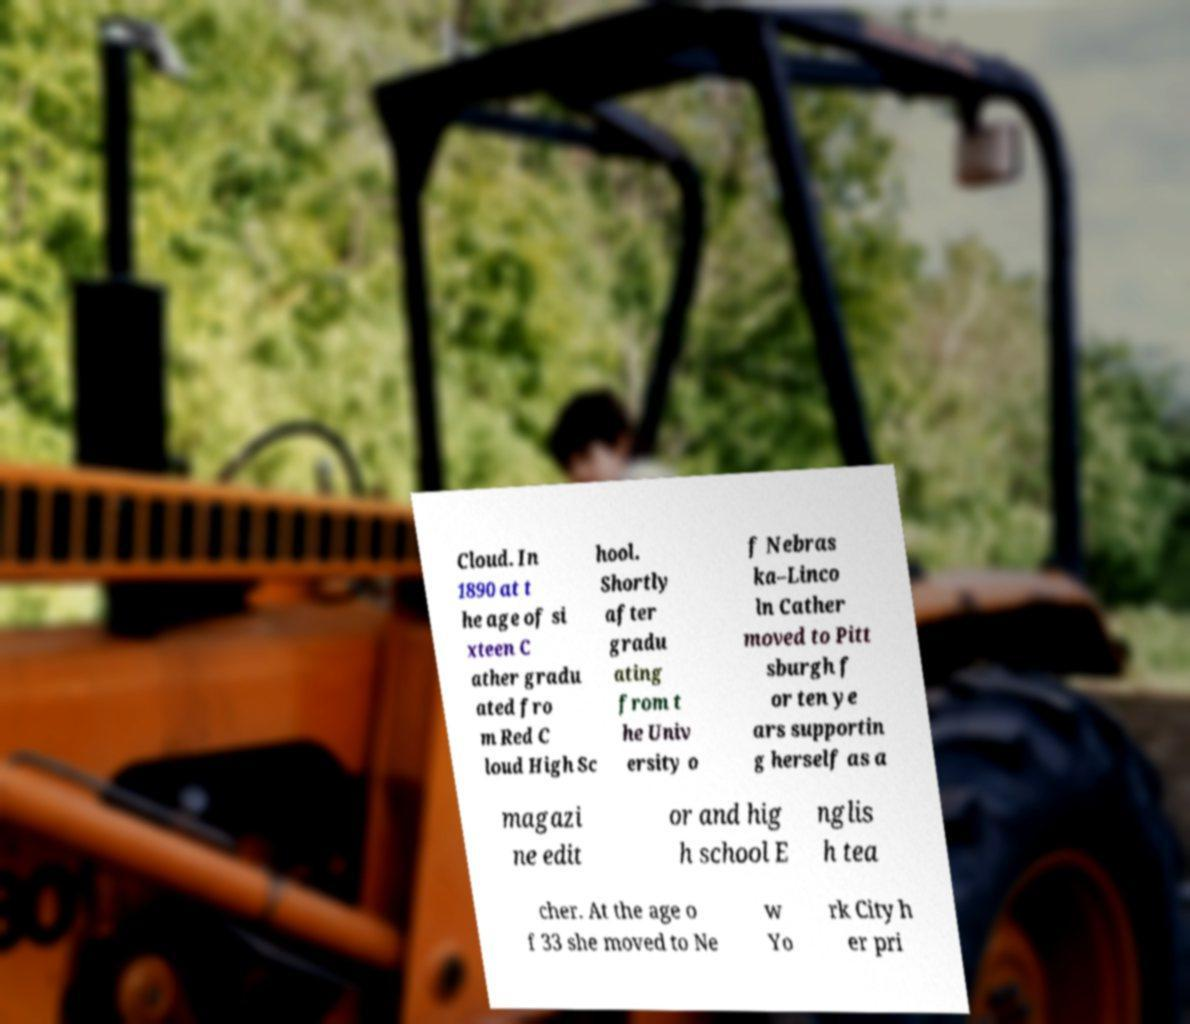Can you accurately transcribe the text from the provided image for me? Cloud. In 1890 at t he age of si xteen C ather gradu ated fro m Red C loud High Sc hool. Shortly after gradu ating from t he Univ ersity o f Nebras ka–Linco ln Cather moved to Pitt sburgh f or ten ye ars supportin g herself as a magazi ne edit or and hig h school E nglis h tea cher. At the age o f 33 she moved to Ne w Yo rk City h er pri 